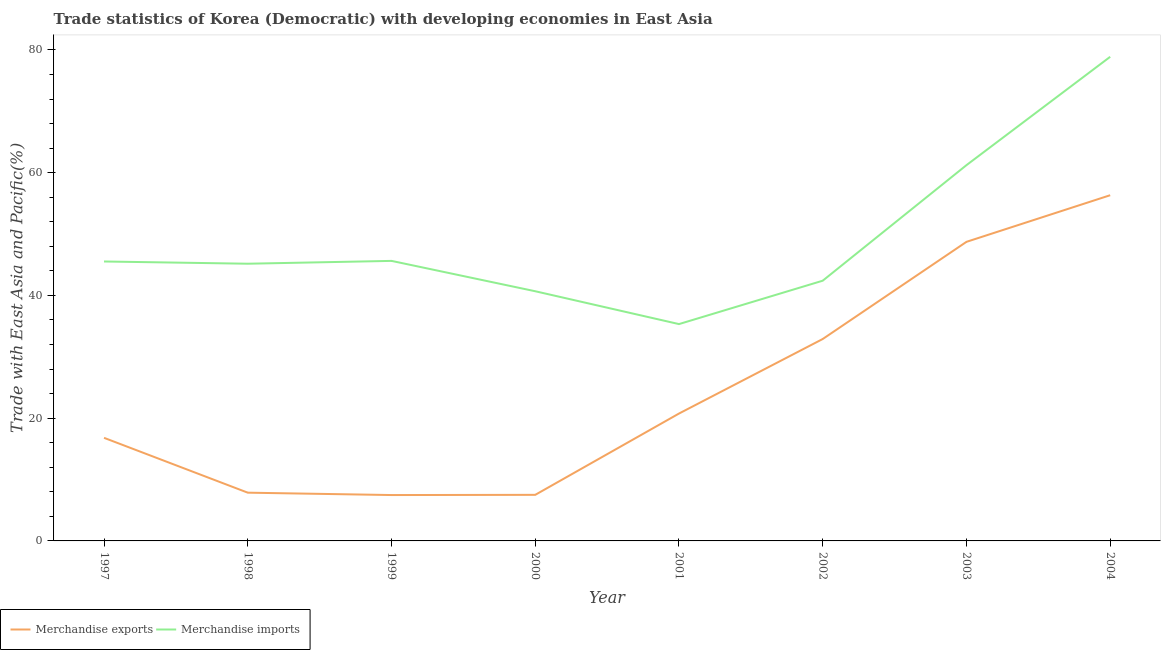How many different coloured lines are there?
Provide a succinct answer. 2. Does the line corresponding to merchandise exports intersect with the line corresponding to merchandise imports?
Provide a succinct answer. No. What is the merchandise exports in 2000?
Your answer should be compact. 7.51. Across all years, what is the maximum merchandise exports?
Make the answer very short. 56.33. Across all years, what is the minimum merchandise imports?
Give a very brief answer. 35.33. In which year was the merchandise imports maximum?
Provide a short and direct response. 2004. In which year was the merchandise imports minimum?
Keep it short and to the point. 2001. What is the total merchandise imports in the graph?
Give a very brief answer. 394.86. What is the difference between the merchandise imports in 1998 and that in 2003?
Your response must be concise. -16.06. What is the difference between the merchandise exports in 2004 and the merchandise imports in 2000?
Keep it short and to the point. 15.65. What is the average merchandise imports per year?
Your answer should be compact. 49.36. In the year 1998, what is the difference between the merchandise exports and merchandise imports?
Offer a very short reply. -37.31. What is the ratio of the merchandise imports in 1997 to that in 1999?
Provide a succinct answer. 1. What is the difference between the highest and the second highest merchandise exports?
Keep it short and to the point. 7.6. What is the difference between the highest and the lowest merchandise exports?
Offer a very short reply. 48.85. Does the merchandise imports monotonically increase over the years?
Provide a succinct answer. No. Is the merchandise imports strictly greater than the merchandise exports over the years?
Make the answer very short. Yes. Is the merchandise imports strictly less than the merchandise exports over the years?
Provide a short and direct response. No. How many lines are there?
Ensure brevity in your answer.  2. What is the difference between two consecutive major ticks on the Y-axis?
Offer a terse response. 20. Does the graph contain grids?
Your answer should be compact. No. How many legend labels are there?
Keep it short and to the point. 2. What is the title of the graph?
Give a very brief answer. Trade statistics of Korea (Democratic) with developing economies in East Asia. Does "Merchandise imports" appear as one of the legend labels in the graph?
Offer a very short reply. Yes. What is the label or title of the Y-axis?
Offer a terse response. Trade with East Asia and Pacific(%). What is the Trade with East Asia and Pacific(%) of Merchandise exports in 1997?
Ensure brevity in your answer.  16.8. What is the Trade with East Asia and Pacific(%) in Merchandise imports in 1997?
Make the answer very short. 45.53. What is the Trade with East Asia and Pacific(%) of Merchandise exports in 1998?
Offer a very short reply. 7.86. What is the Trade with East Asia and Pacific(%) of Merchandise imports in 1998?
Give a very brief answer. 45.17. What is the Trade with East Asia and Pacific(%) in Merchandise exports in 1999?
Your answer should be very brief. 7.48. What is the Trade with East Asia and Pacific(%) of Merchandise imports in 1999?
Offer a very short reply. 45.63. What is the Trade with East Asia and Pacific(%) in Merchandise exports in 2000?
Offer a terse response. 7.51. What is the Trade with East Asia and Pacific(%) of Merchandise imports in 2000?
Make the answer very short. 40.68. What is the Trade with East Asia and Pacific(%) of Merchandise exports in 2001?
Offer a terse response. 20.75. What is the Trade with East Asia and Pacific(%) in Merchandise imports in 2001?
Your response must be concise. 35.33. What is the Trade with East Asia and Pacific(%) of Merchandise exports in 2002?
Offer a terse response. 32.9. What is the Trade with East Asia and Pacific(%) of Merchandise imports in 2002?
Keep it short and to the point. 42.4. What is the Trade with East Asia and Pacific(%) of Merchandise exports in 2003?
Keep it short and to the point. 48.73. What is the Trade with East Asia and Pacific(%) in Merchandise imports in 2003?
Keep it short and to the point. 61.23. What is the Trade with East Asia and Pacific(%) in Merchandise exports in 2004?
Give a very brief answer. 56.33. What is the Trade with East Asia and Pacific(%) of Merchandise imports in 2004?
Ensure brevity in your answer.  78.89. Across all years, what is the maximum Trade with East Asia and Pacific(%) of Merchandise exports?
Give a very brief answer. 56.33. Across all years, what is the maximum Trade with East Asia and Pacific(%) of Merchandise imports?
Give a very brief answer. 78.89. Across all years, what is the minimum Trade with East Asia and Pacific(%) of Merchandise exports?
Give a very brief answer. 7.48. Across all years, what is the minimum Trade with East Asia and Pacific(%) in Merchandise imports?
Offer a very short reply. 35.33. What is the total Trade with East Asia and Pacific(%) in Merchandise exports in the graph?
Make the answer very short. 198.36. What is the total Trade with East Asia and Pacific(%) of Merchandise imports in the graph?
Your response must be concise. 394.86. What is the difference between the Trade with East Asia and Pacific(%) in Merchandise exports in 1997 and that in 1998?
Provide a short and direct response. 8.94. What is the difference between the Trade with East Asia and Pacific(%) in Merchandise imports in 1997 and that in 1998?
Your response must be concise. 0.36. What is the difference between the Trade with East Asia and Pacific(%) of Merchandise exports in 1997 and that in 1999?
Keep it short and to the point. 9.32. What is the difference between the Trade with East Asia and Pacific(%) in Merchandise imports in 1997 and that in 1999?
Provide a short and direct response. -0.1. What is the difference between the Trade with East Asia and Pacific(%) of Merchandise exports in 1997 and that in 2000?
Your answer should be very brief. 9.29. What is the difference between the Trade with East Asia and Pacific(%) in Merchandise imports in 1997 and that in 2000?
Keep it short and to the point. 4.85. What is the difference between the Trade with East Asia and Pacific(%) in Merchandise exports in 1997 and that in 2001?
Your answer should be very brief. -3.95. What is the difference between the Trade with East Asia and Pacific(%) in Merchandise imports in 1997 and that in 2001?
Offer a terse response. 10.2. What is the difference between the Trade with East Asia and Pacific(%) in Merchandise exports in 1997 and that in 2002?
Keep it short and to the point. -16.1. What is the difference between the Trade with East Asia and Pacific(%) of Merchandise imports in 1997 and that in 2002?
Give a very brief answer. 3.13. What is the difference between the Trade with East Asia and Pacific(%) of Merchandise exports in 1997 and that in 2003?
Your answer should be compact. -31.93. What is the difference between the Trade with East Asia and Pacific(%) in Merchandise imports in 1997 and that in 2003?
Keep it short and to the point. -15.7. What is the difference between the Trade with East Asia and Pacific(%) in Merchandise exports in 1997 and that in 2004?
Your response must be concise. -39.53. What is the difference between the Trade with East Asia and Pacific(%) in Merchandise imports in 1997 and that in 2004?
Give a very brief answer. -33.35. What is the difference between the Trade with East Asia and Pacific(%) in Merchandise exports in 1998 and that in 1999?
Offer a terse response. 0.39. What is the difference between the Trade with East Asia and Pacific(%) of Merchandise imports in 1998 and that in 1999?
Give a very brief answer. -0.46. What is the difference between the Trade with East Asia and Pacific(%) of Merchandise exports in 1998 and that in 2000?
Offer a very short reply. 0.35. What is the difference between the Trade with East Asia and Pacific(%) in Merchandise imports in 1998 and that in 2000?
Provide a succinct answer. 4.48. What is the difference between the Trade with East Asia and Pacific(%) of Merchandise exports in 1998 and that in 2001?
Offer a terse response. -12.89. What is the difference between the Trade with East Asia and Pacific(%) in Merchandise imports in 1998 and that in 2001?
Your response must be concise. 9.84. What is the difference between the Trade with East Asia and Pacific(%) of Merchandise exports in 1998 and that in 2002?
Give a very brief answer. -25.04. What is the difference between the Trade with East Asia and Pacific(%) of Merchandise imports in 1998 and that in 2002?
Offer a terse response. 2.77. What is the difference between the Trade with East Asia and Pacific(%) in Merchandise exports in 1998 and that in 2003?
Offer a very short reply. -40.87. What is the difference between the Trade with East Asia and Pacific(%) of Merchandise imports in 1998 and that in 2003?
Offer a very short reply. -16.06. What is the difference between the Trade with East Asia and Pacific(%) in Merchandise exports in 1998 and that in 2004?
Your answer should be compact. -48.47. What is the difference between the Trade with East Asia and Pacific(%) in Merchandise imports in 1998 and that in 2004?
Your response must be concise. -33.72. What is the difference between the Trade with East Asia and Pacific(%) of Merchandise exports in 1999 and that in 2000?
Your answer should be compact. -0.03. What is the difference between the Trade with East Asia and Pacific(%) in Merchandise imports in 1999 and that in 2000?
Offer a terse response. 4.95. What is the difference between the Trade with East Asia and Pacific(%) in Merchandise exports in 1999 and that in 2001?
Give a very brief answer. -13.28. What is the difference between the Trade with East Asia and Pacific(%) of Merchandise imports in 1999 and that in 2001?
Your answer should be very brief. 10.3. What is the difference between the Trade with East Asia and Pacific(%) of Merchandise exports in 1999 and that in 2002?
Your response must be concise. -25.42. What is the difference between the Trade with East Asia and Pacific(%) in Merchandise imports in 1999 and that in 2002?
Offer a very short reply. 3.23. What is the difference between the Trade with East Asia and Pacific(%) in Merchandise exports in 1999 and that in 2003?
Offer a terse response. -41.26. What is the difference between the Trade with East Asia and Pacific(%) of Merchandise imports in 1999 and that in 2003?
Provide a succinct answer. -15.6. What is the difference between the Trade with East Asia and Pacific(%) of Merchandise exports in 1999 and that in 2004?
Keep it short and to the point. -48.85. What is the difference between the Trade with East Asia and Pacific(%) of Merchandise imports in 1999 and that in 2004?
Keep it short and to the point. -33.26. What is the difference between the Trade with East Asia and Pacific(%) in Merchandise exports in 2000 and that in 2001?
Give a very brief answer. -13.25. What is the difference between the Trade with East Asia and Pacific(%) in Merchandise imports in 2000 and that in 2001?
Offer a very short reply. 5.35. What is the difference between the Trade with East Asia and Pacific(%) in Merchandise exports in 2000 and that in 2002?
Offer a terse response. -25.39. What is the difference between the Trade with East Asia and Pacific(%) of Merchandise imports in 2000 and that in 2002?
Your response must be concise. -1.72. What is the difference between the Trade with East Asia and Pacific(%) of Merchandise exports in 2000 and that in 2003?
Ensure brevity in your answer.  -41.22. What is the difference between the Trade with East Asia and Pacific(%) in Merchandise imports in 2000 and that in 2003?
Ensure brevity in your answer.  -20.54. What is the difference between the Trade with East Asia and Pacific(%) of Merchandise exports in 2000 and that in 2004?
Offer a terse response. -48.82. What is the difference between the Trade with East Asia and Pacific(%) in Merchandise imports in 2000 and that in 2004?
Make the answer very short. -38.2. What is the difference between the Trade with East Asia and Pacific(%) of Merchandise exports in 2001 and that in 2002?
Keep it short and to the point. -12.14. What is the difference between the Trade with East Asia and Pacific(%) of Merchandise imports in 2001 and that in 2002?
Give a very brief answer. -7.07. What is the difference between the Trade with East Asia and Pacific(%) in Merchandise exports in 2001 and that in 2003?
Offer a very short reply. -27.98. What is the difference between the Trade with East Asia and Pacific(%) of Merchandise imports in 2001 and that in 2003?
Provide a short and direct response. -25.9. What is the difference between the Trade with East Asia and Pacific(%) in Merchandise exports in 2001 and that in 2004?
Your response must be concise. -35.58. What is the difference between the Trade with East Asia and Pacific(%) in Merchandise imports in 2001 and that in 2004?
Offer a very short reply. -43.55. What is the difference between the Trade with East Asia and Pacific(%) of Merchandise exports in 2002 and that in 2003?
Offer a very short reply. -15.83. What is the difference between the Trade with East Asia and Pacific(%) in Merchandise imports in 2002 and that in 2003?
Your answer should be very brief. -18.83. What is the difference between the Trade with East Asia and Pacific(%) of Merchandise exports in 2002 and that in 2004?
Give a very brief answer. -23.43. What is the difference between the Trade with East Asia and Pacific(%) in Merchandise imports in 2002 and that in 2004?
Keep it short and to the point. -36.49. What is the difference between the Trade with East Asia and Pacific(%) in Merchandise exports in 2003 and that in 2004?
Give a very brief answer. -7.6. What is the difference between the Trade with East Asia and Pacific(%) of Merchandise imports in 2003 and that in 2004?
Ensure brevity in your answer.  -17.66. What is the difference between the Trade with East Asia and Pacific(%) in Merchandise exports in 1997 and the Trade with East Asia and Pacific(%) in Merchandise imports in 1998?
Make the answer very short. -28.37. What is the difference between the Trade with East Asia and Pacific(%) in Merchandise exports in 1997 and the Trade with East Asia and Pacific(%) in Merchandise imports in 1999?
Your answer should be compact. -28.83. What is the difference between the Trade with East Asia and Pacific(%) in Merchandise exports in 1997 and the Trade with East Asia and Pacific(%) in Merchandise imports in 2000?
Your answer should be compact. -23.88. What is the difference between the Trade with East Asia and Pacific(%) in Merchandise exports in 1997 and the Trade with East Asia and Pacific(%) in Merchandise imports in 2001?
Keep it short and to the point. -18.53. What is the difference between the Trade with East Asia and Pacific(%) of Merchandise exports in 1997 and the Trade with East Asia and Pacific(%) of Merchandise imports in 2002?
Offer a very short reply. -25.6. What is the difference between the Trade with East Asia and Pacific(%) of Merchandise exports in 1997 and the Trade with East Asia and Pacific(%) of Merchandise imports in 2003?
Your answer should be compact. -44.43. What is the difference between the Trade with East Asia and Pacific(%) of Merchandise exports in 1997 and the Trade with East Asia and Pacific(%) of Merchandise imports in 2004?
Offer a terse response. -62.09. What is the difference between the Trade with East Asia and Pacific(%) in Merchandise exports in 1998 and the Trade with East Asia and Pacific(%) in Merchandise imports in 1999?
Make the answer very short. -37.77. What is the difference between the Trade with East Asia and Pacific(%) of Merchandise exports in 1998 and the Trade with East Asia and Pacific(%) of Merchandise imports in 2000?
Offer a very short reply. -32.82. What is the difference between the Trade with East Asia and Pacific(%) of Merchandise exports in 1998 and the Trade with East Asia and Pacific(%) of Merchandise imports in 2001?
Your answer should be compact. -27.47. What is the difference between the Trade with East Asia and Pacific(%) of Merchandise exports in 1998 and the Trade with East Asia and Pacific(%) of Merchandise imports in 2002?
Make the answer very short. -34.54. What is the difference between the Trade with East Asia and Pacific(%) of Merchandise exports in 1998 and the Trade with East Asia and Pacific(%) of Merchandise imports in 2003?
Offer a terse response. -53.37. What is the difference between the Trade with East Asia and Pacific(%) in Merchandise exports in 1998 and the Trade with East Asia and Pacific(%) in Merchandise imports in 2004?
Offer a terse response. -71.02. What is the difference between the Trade with East Asia and Pacific(%) in Merchandise exports in 1999 and the Trade with East Asia and Pacific(%) in Merchandise imports in 2000?
Your answer should be compact. -33.21. What is the difference between the Trade with East Asia and Pacific(%) of Merchandise exports in 1999 and the Trade with East Asia and Pacific(%) of Merchandise imports in 2001?
Provide a succinct answer. -27.86. What is the difference between the Trade with East Asia and Pacific(%) in Merchandise exports in 1999 and the Trade with East Asia and Pacific(%) in Merchandise imports in 2002?
Make the answer very short. -34.92. What is the difference between the Trade with East Asia and Pacific(%) of Merchandise exports in 1999 and the Trade with East Asia and Pacific(%) of Merchandise imports in 2003?
Your answer should be compact. -53.75. What is the difference between the Trade with East Asia and Pacific(%) of Merchandise exports in 1999 and the Trade with East Asia and Pacific(%) of Merchandise imports in 2004?
Ensure brevity in your answer.  -71.41. What is the difference between the Trade with East Asia and Pacific(%) in Merchandise exports in 2000 and the Trade with East Asia and Pacific(%) in Merchandise imports in 2001?
Give a very brief answer. -27.82. What is the difference between the Trade with East Asia and Pacific(%) of Merchandise exports in 2000 and the Trade with East Asia and Pacific(%) of Merchandise imports in 2002?
Your answer should be very brief. -34.89. What is the difference between the Trade with East Asia and Pacific(%) of Merchandise exports in 2000 and the Trade with East Asia and Pacific(%) of Merchandise imports in 2003?
Offer a terse response. -53.72. What is the difference between the Trade with East Asia and Pacific(%) of Merchandise exports in 2000 and the Trade with East Asia and Pacific(%) of Merchandise imports in 2004?
Ensure brevity in your answer.  -71.38. What is the difference between the Trade with East Asia and Pacific(%) of Merchandise exports in 2001 and the Trade with East Asia and Pacific(%) of Merchandise imports in 2002?
Offer a terse response. -21.65. What is the difference between the Trade with East Asia and Pacific(%) in Merchandise exports in 2001 and the Trade with East Asia and Pacific(%) in Merchandise imports in 2003?
Your answer should be very brief. -40.47. What is the difference between the Trade with East Asia and Pacific(%) in Merchandise exports in 2001 and the Trade with East Asia and Pacific(%) in Merchandise imports in 2004?
Ensure brevity in your answer.  -58.13. What is the difference between the Trade with East Asia and Pacific(%) of Merchandise exports in 2002 and the Trade with East Asia and Pacific(%) of Merchandise imports in 2003?
Offer a terse response. -28.33. What is the difference between the Trade with East Asia and Pacific(%) of Merchandise exports in 2002 and the Trade with East Asia and Pacific(%) of Merchandise imports in 2004?
Offer a very short reply. -45.99. What is the difference between the Trade with East Asia and Pacific(%) in Merchandise exports in 2003 and the Trade with East Asia and Pacific(%) in Merchandise imports in 2004?
Offer a terse response. -30.15. What is the average Trade with East Asia and Pacific(%) of Merchandise exports per year?
Your answer should be very brief. 24.8. What is the average Trade with East Asia and Pacific(%) in Merchandise imports per year?
Give a very brief answer. 49.36. In the year 1997, what is the difference between the Trade with East Asia and Pacific(%) in Merchandise exports and Trade with East Asia and Pacific(%) in Merchandise imports?
Provide a succinct answer. -28.73. In the year 1998, what is the difference between the Trade with East Asia and Pacific(%) of Merchandise exports and Trade with East Asia and Pacific(%) of Merchandise imports?
Give a very brief answer. -37.31. In the year 1999, what is the difference between the Trade with East Asia and Pacific(%) of Merchandise exports and Trade with East Asia and Pacific(%) of Merchandise imports?
Make the answer very short. -38.15. In the year 2000, what is the difference between the Trade with East Asia and Pacific(%) of Merchandise exports and Trade with East Asia and Pacific(%) of Merchandise imports?
Make the answer very short. -33.18. In the year 2001, what is the difference between the Trade with East Asia and Pacific(%) in Merchandise exports and Trade with East Asia and Pacific(%) in Merchandise imports?
Your response must be concise. -14.58. In the year 2002, what is the difference between the Trade with East Asia and Pacific(%) in Merchandise exports and Trade with East Asia and Pacific(%) in Merchandise imports?
Ensure brevity in your answer.  -9.5. In the year 2003, what is the difference between the Trade with East Asia and Pacific(%) of Merchandise exports and Trade with East Asia and Pacific(%) of Merchandise imports?
Your answer should be very brief. -12.5. In the year 2004, what is the difference between the Trade with East Asia and Pacific(%) in Merchandise exports and Trade with East Asia and Pacific(%) in Merchandise imports?
Provide a succinct answer. -22.56. What is the ratio of the Trade with East Asia and Pacific(%) of Merchandise exports in 1997 to that in 1998?
Make the answer very short. 2.14. What is the ratio of the Trade with East Asia and Pacific(%) of Merchandise exports in 1997 to that in 1999?
Make the answer very short. 2.25. What is the ratio of the Trade with East Asia and Pacific(%) of Merchandise imports in 1997 to that in 1999?
Make the answer very short. 1. What is the ratio of the Trade with East Asia and Pacific(%) of Merchandise exports in 1997 to that in 2000?
Provide a short and direct response. 2.24. What is the ratio of the Trade with East Asia and Pacific(%) in Merchandise imports in 1997 to that in 2000?
Make the answer very short. 1.12. What is the ratio of the Trade with East Asia and Pacific(%) in Merchandise exports in 1997 to that in 2001?
Keep it short and to the point. 0.81. What is the ratio of the Trade with East Asia and Pacific(%) in Merchandise imports in 1997 to that in 2001?
Ensure brevity in your answer.  1.29. What is the ratio of the Trade with East Asia and Pacific(%) in Merchandise exports in 1997 to that in 2002?
Offer a terse response. 0.51. What is the ratio of the Trade with East Asia and Pacific(%) in Merchandise imports in 1997 to that in 2002?
Make the answer very short. 1.07. What is the ratio of the Trade with East Asia and Pacific(%) in Merchandise exports in 1997 to that in 2003?
Make the answer very short. 0.34. What is the ratio of the Trade with East Asia and Pacific(%) in Merchandise imports in 1997 to that in 2003?
Your answer should be very brief. 0.74. What is the ratio of the Trade with East Asia and Pacific(%) of Merchandise exports in 1997 to that in 2004?
Provide a short and direct response. 0.3. What is the ratio of the Trade with East Asia and Pacific(%) in Merchandise imports in 1997 to that in 2004?
Your answer should be compact. 0.58. What is the ratio of the Trade with East Asia and Pacific(%) of Merchandise exports in 1998 to that in 1999?
Make the answer very short. 1.05. What is the ratio of the Trade with East Asia and Pacific(%) of Merchandise exports in 1998 to that in 2000?
Make the answer very short. 1.05. What is the ratio of the Trade with East Asia and Pacific(%) in Merchandise imports in 1998 to that in 2000?
Offer a very short reply. 1.11. What is the ratio of the Trade with East Asia and Pacific(%) of Merchandise exports in 1998 to that in 2001?
Offer a very short reply. 0.38. What is the ratio of the Trade with East Asia and Pacific(%) in Merchandise imports in 1998 to that in 2001?
Your answer should be very brief. 1.28. What is the ratio of the Trade with East Asia and Pacific(%) of Merchandise exports in 1998 to that in 2002?
Ensure brevity in your answer.  0.24. What is the ratio of the Trade with East Asia and Pacific(%) in Merchandise imports in 1998 to that in 2002?
Keep it short and to the point. 1.07. What is the ratio of the Trade with East Asia and Pacific(%) of Merchandise exports in 1998 to that in 2003?
Give a very brief answer. 0.16. What is the ratio of the Trade with East Asia and Pacific(%) in Merchandise imports in 1998 to that in 2003?
Your answer should be very brief. 0.74. What is the ratio of the Trade with East Asia and Pacific(%) of Merchandise exports in 1998 to that in 2004?
Ensure brevity in your answer.  0.14. What is the ratio of the Trade with East Asia and Pacific(%) in Merchandise imports in 1998 to that in 2004?
Your answer should be compact. 0.57. What is the ratio of the Trade with East Asia and Pacific(%) of Merchandise imports in 1999 to that in 2000?
Ensure brevity in your answer.  1.12. What is the ratio of the Trade with East Asia and Pacific(%) of Merchandise exports in 1999 to that in 2001?
Offer a very short reply. 0.36. What is the ratio of the Trade with East Asia and Pacific(%) of Merchandise imports in 1999 to that in 2001?
Your answer should be very brief. 1.29. What is the ratio of the Trade with East Asia and Pacific(%) of Merchandise exports in 1999 to that in 2002?
Provide a short and direct response. 0.23. What is the ratio of the Trade with East Asia and Pacific(%) of Merchandise imports in 1999 to that in 2002?
Your answer should be very brief. 1.08. What is the ratio of the Trade with East Asia and Pacific(%) in Merchandise exports in 1999 to that in 2003?
Your answer should be very brief. 0.15. What is the ratio of the Trade with East Asia and Pacific(%) in Merchandise imports in 1999 to that in 2003?
Offer a terse response. 0.75. What is the ratio of the Trade with East Asia and Pacific(%) in Merchandise exports in 1999 to that in 2004?
Your response must be concise. 0.13. What is the ratio of the Trade with East Asia and Pacific(%) of Merchandise imports in 1999 to that in 2004?
Your answer should be compact. 0.58. What is the ratio of the Trade with East Asia and Pacific(%) in Merchandise exports in 2000 to that in 2001?
Provide a succinct answer. 0.36. What is the ratio of the Trade with East Asia and Pacific(%) of Merchandise imports in 2000 to that in 2001?
Your answer should be compact. 1.15. What is the ratio of the Trade with East Asia and Pacific(%) of Merchandise exports in 2000 to that in 2002?
Ensure brevity in your answer.  0.23. What is the ratio of the Trade with East Asia and Pacific(%) of Merchandise imports in 2000 to that in 2002?
Your response must be concise. 0.96. What is the ratio of the Trade with East Asia and Pacific(%) in Merchandise exports in 2000 to that in 2003?
Provide a succinct answer. 0.15. What is the ratio of the Trade with East Asia and Pacific(%) of Merchandise imports in 2000 to that in 2003?
Your answer should be very brief. 0.66. What is the ratio of the Trade with East Asia and Pacific(%) in Merchandise exports in 2000 to that in 2004?
Your answer should be very brief. 0.13. What is the ratio of the Trade with East Asia and Pacific(%) of Merchandise imports in 2000 to that in 2004?
Make the answer very short. 0.52. What is the ratio of the Trade with East Asia and Pacific(%) in Merchandise exports in 2001 to that in 2002?
Ensure brevity in your answer.  0.63. What is the ratio of the Trade with East Asia and Pacific(%) of Merchandise imports in 2001 to that in 2002?
Your answer should be compact. 0.83. What is the ratio of the Trade with East Asia and Pacific(%) of Merchandise exports in 2001 to that in 2003?
Provide a succinct answer. 0.43. What is the ratio of the Trade with East Asia and Pacific(%) of Merchandise imports in 2001 to that in 2003?
Ensure brevity in your answer.  0.58. What is the ratio of the Trade with East Asia and Pacific(%) in Merchandise exports in 2001 to that in 2004?
Provide a short and direct response. 0.37. What is the ratio of the Trade with East Asia and Pacific(%) of Merchandise imports in 2001 to that in 2004?
Offer a terse response. 0.45. What is the ratio of the Trade with East Asia and Pacific(%) of Merchandise exports in 2002 to that in 2003?
Your answer should be very brief. 0.68. What is the ratio of the Trade with East Asia and Pacific(%) of Merchandise imports in 2002 to that in 2003?
Ensure brevity in your answer.  0.69. What is the ratio of the Trade with East Asia and Pacific(%) of Merchandise exports in 2002 to that in 2004?
Provide a succinct answer. 0.58. What is the ratio of the Trade with East Asia and Pacific(%) of Merchandise imports in 2002 to that in 2004?
Offer a very short reply. 0.54. What is the ratio of the Trade with East Asia and Pacific(%) of Merchandise exports in 2003 to that in 2004?
Provide a short and direct response. 0.87. What is the ratio of the Trade with East Asia and Pacific(%) in Merchandise imports in 2003 to that in 2004?
Give a very brief answer. 0.78. What is the difference between the highest and the second highest Trade with East Asia and Pacific(%) of Merchandise exports?
Ensure brevity in your answer.  7.6. What is the difference between the highest and the second highest Trade with East Asia and Pacific(%) in Merchandise imports?
Offer a terse response. 17.66. What is the difference between the highest and the lowest Trade with East Asia and Pacific(%) in Merchandise exports?
Your response must be concise. 48.85. What is the difference between the highest and the lowest Trade with East Asia and Pacific(%) in Merchandise imports?
Make the answer very short. 43.55. 